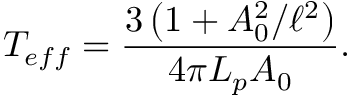Convert formula to latex. <formula><loc_0><loc_0><loc_500><loc_500>T _ { e f f } = \frac { 3 \left ( 1 + A _ { 0 } ^ { 2 } / \ell ^ { 2 } \right ) } { 4 \pi L _ { p } A _ { 0 } } .</formula> 